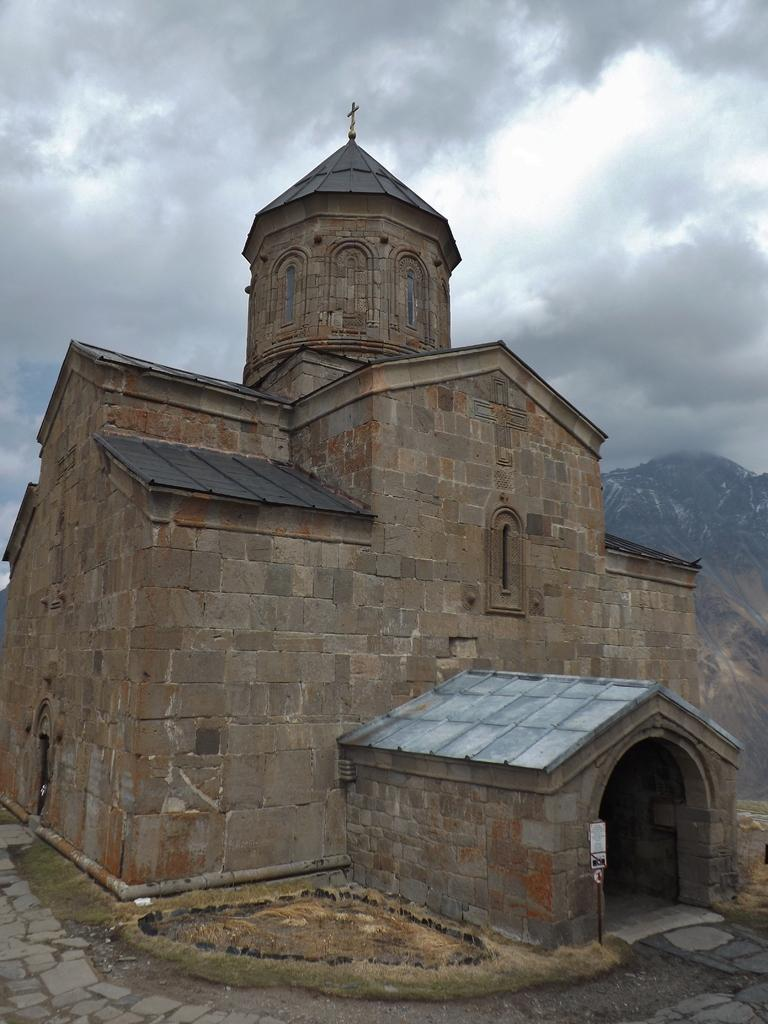What type of building is shown in the image? The image depicts a church building. Can you describe any additional features of the church? Yes, there is a board attached to a pole in the image. What religious symbol can be seen at the top of the spire? A holy cross symbol is present at the top of the spire. What is visible in the sky in the image? Clouds are visible in the sky. How many umbrellas are being used by the winged creatures in the image? There are no winged creatures or umbrellas present in the image. What emotion is the church feeling in the image? The church is an inanimate object and does not have emotions like shame or any other feelings. 